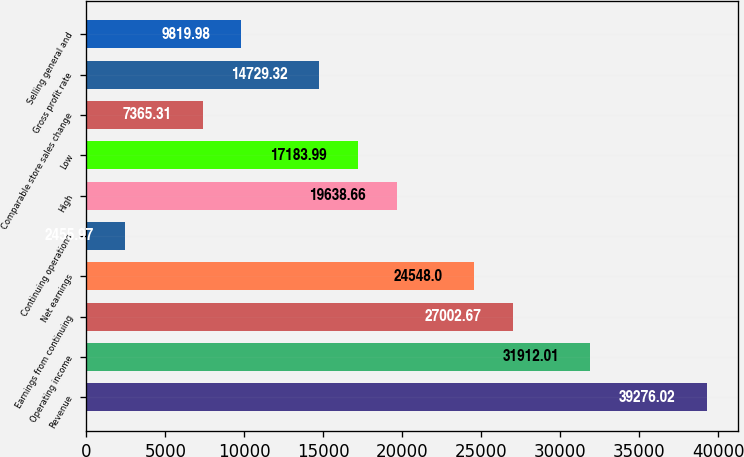Convert chart to OTSL. <chart><loc_0><loc_0><loc_500><loc_500><bar_chart><fcel>Revenue<fcel>Operating income<fcel>Earnings from continuing<fcel>Net earnings<fcel>Continuing operations<fcel>High<fcel>Low<fcel>Comparable store sales change<fcel>Gross profit rate<fcel>Selling general and<nl><fcel>39276<fcel>31912<fcel>27002.7<fcel>24548<fcel>2455.97<fcel>19638.7<fcel>17184<fcel>7365.31<fcel>14729.3<fcel>9819.98<nl></chart> 